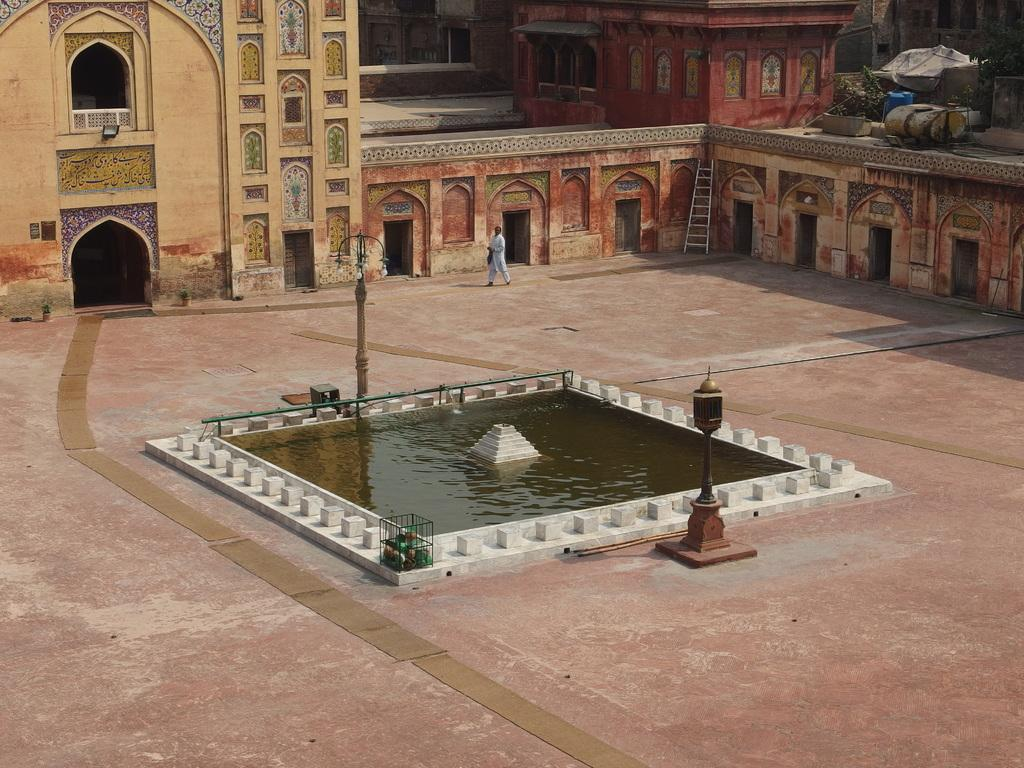What is the main feature in the center of the image? There is water in the center of the image. What structures can be seen in the image? There are poles in the image. What is happening in the background of the image? A man is walking in the background of the image, and there is a fort present. What is located on the right side of the image? There is a wall on the right side of the image. What type of birds can be seen sitting on the committee in the image? There is no committee or birds present in the image. 